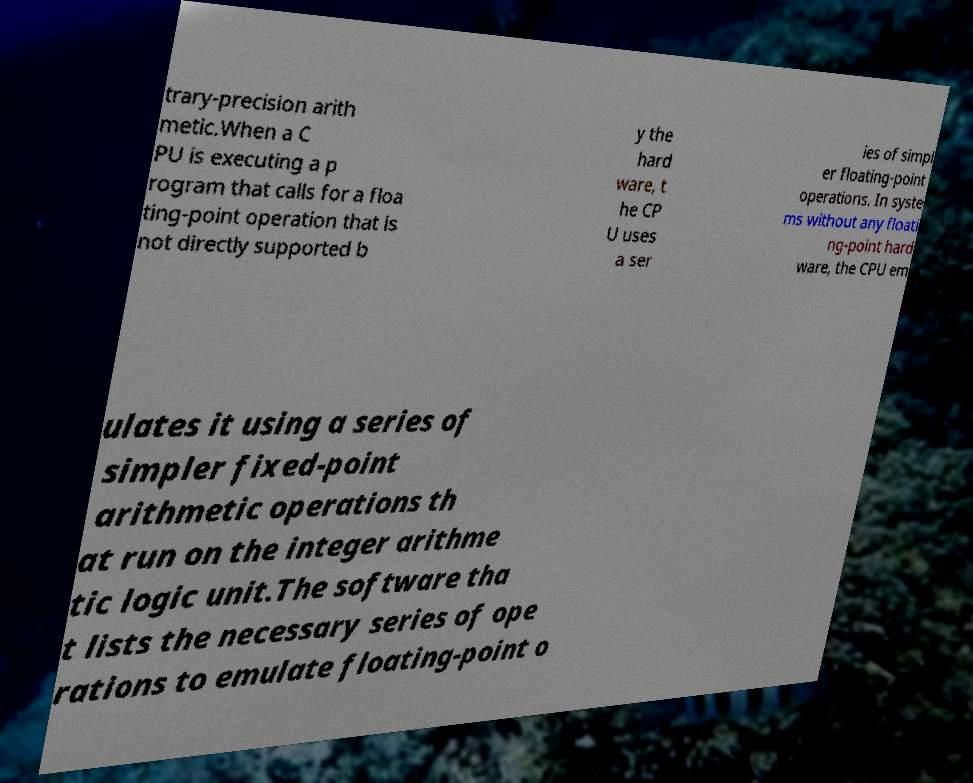What messages or text are displayed in this image? I need them in a readable, typed format. trary-precision arith metic.When a C PU is executing a p rogram that calls for a floa ting-point operation that is not directly supported b y the hard ware, t he CP U uses a ser ies of simpl er floating-point operations. In syste ms without any floati ng-point hard ware, the CPU em ulates it using a series of simpler fixed-point arithmetic operations th at run on the integer arithme tic logic unit.The software tha t lists the necessary series of ope rations to emulate floating-point o 